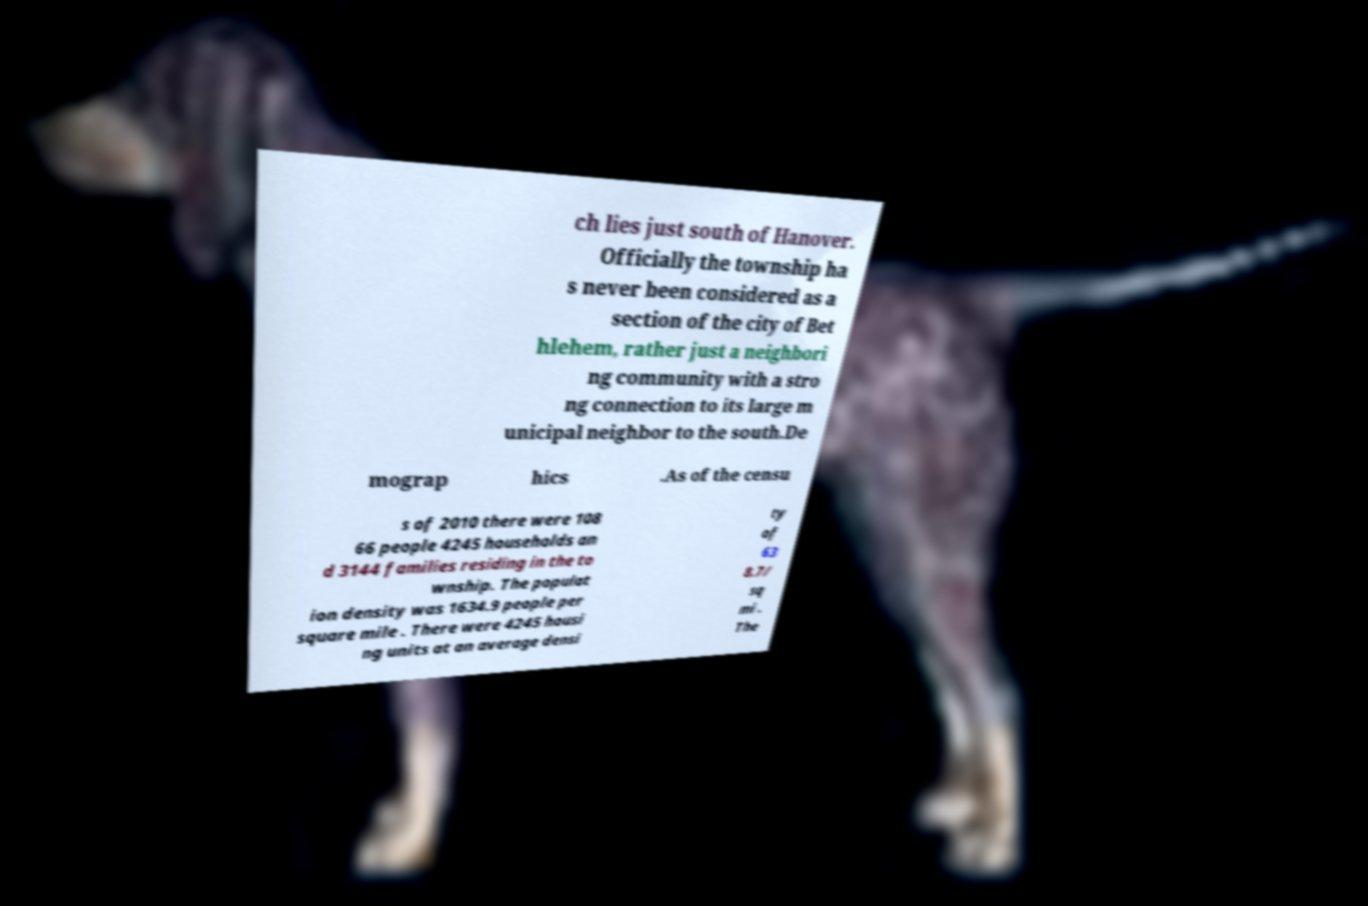Can you read and provide the text displayed in the image?This photo seems to have some interesting text. Can you extract and type it out for me? ch lies just south of Hanover. Officially the township ha s never been considered as a section of the city of Bet hlehem, rather just a neighbori ng community with a stro ng connection to its large m unicipal neighbor to the south.De mograp hics .As of the censu s of 2010 there were 108 66 people 4245 households an d 3144 families residing in the to wnship. The populat ion density was 1634.9 people per square mile . There were 4245 housi ng units at an average densi ty of 63 8.7/ sq mi . The 